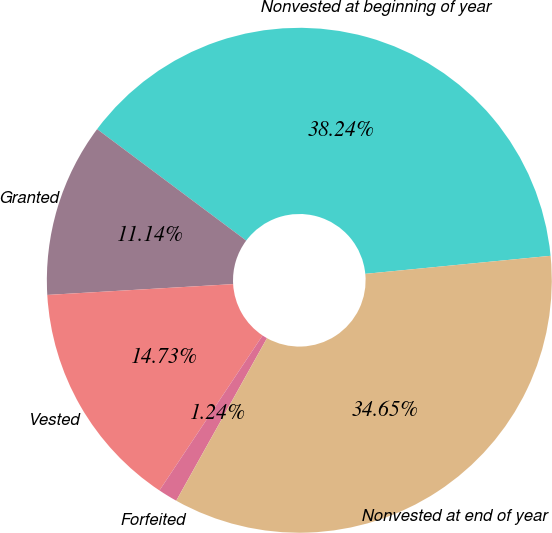Convert chart. <chart><loc_0><loc_0><loc_500><loc_500><pie_chart><fcel>Nonvested at beginning of year<fcel>Granted<fcel>Vested<fcel>Forfeited<fcel>Nonvested at end of year<nl><fcel>38.24%<fcel>11.14%<fcel>14.73%<fcel>1.24%<fcel>34.65%<nl></chart> 